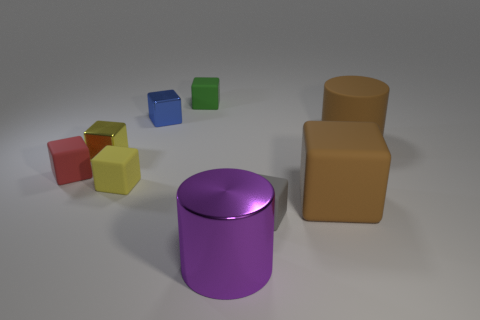Subtract all gray blocks. How many blocks are left? 6 Subtract all green cubes. How many cubes are left? 6 Subtract all purple blocks. Subtract all brown spheres. How many blocks are left? 7 Add 1 big brown objects. How many objects exist? 10 Subtract all blocks. How many objects are left? 2 Subtract 0 cyan blocks. How many objects are left? 9 Subtract all small blue metal cubes. Subtract all tiny blue things. How many objects are left? 7 Add 4 yellow matte blocks. How many yellow matte blocks are left? 5 Add 7 big purple shiny cylinders. How many big purple shiny cylinders exist? 8 